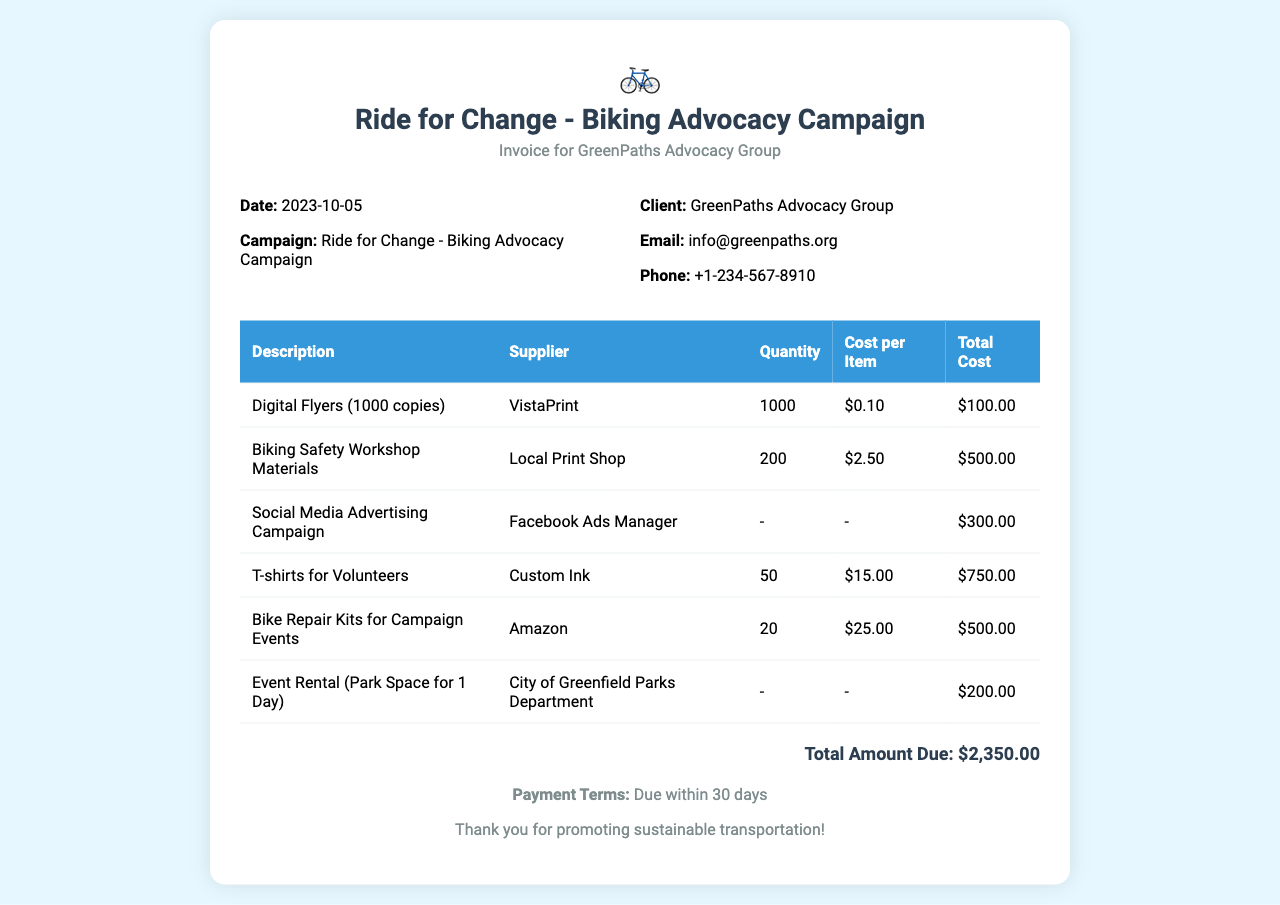What is the campaign title? The campaign title is prominently featured at the top of the document, indicating the purpose of the invoice.
Answer: Ride for Change - Biking Advocacy Campaign What is the total amount due? The total amount due is indicated at the bottom of the invoice, summarizing the costs associated with the campaign.
Answer: $2,350.00 Who is the supplier of the T-shirts for volunteers? The supplier's name for the T-shirts can be found in the corresponding row of the invoice table.
Answer: Custom Ink How many digital flyers were ordered? The quantity of digital flyers is listed in the invoice table, specifying the number of copies ordered.
Answer: 1000 What is the date of the invoice? The date is located near the top of the invoice, providing the date the invoice was issued.
Answer: 2023-10-05 What is the cost per item for biking safety workshop materials? The cost per item for biking safety workshop materials is detailed in the table, showing the expense for each material.
Answer: $2.50 How many bike repair kits were ordered? The number of bike repair kits is outlined in the invoice table, revealing how many were procured for the campaign.
Answer: 20 Who is the client? The client's name is listed under the invoice details section, indicating the organization receiving the invoice.
Answer: GreenPaths Advocacy Group What is the payment term specified in the invoice? The payment term is mentioned in the footer section of the invoice, outlining when payment is expected.
Answer: Due within 30 days 